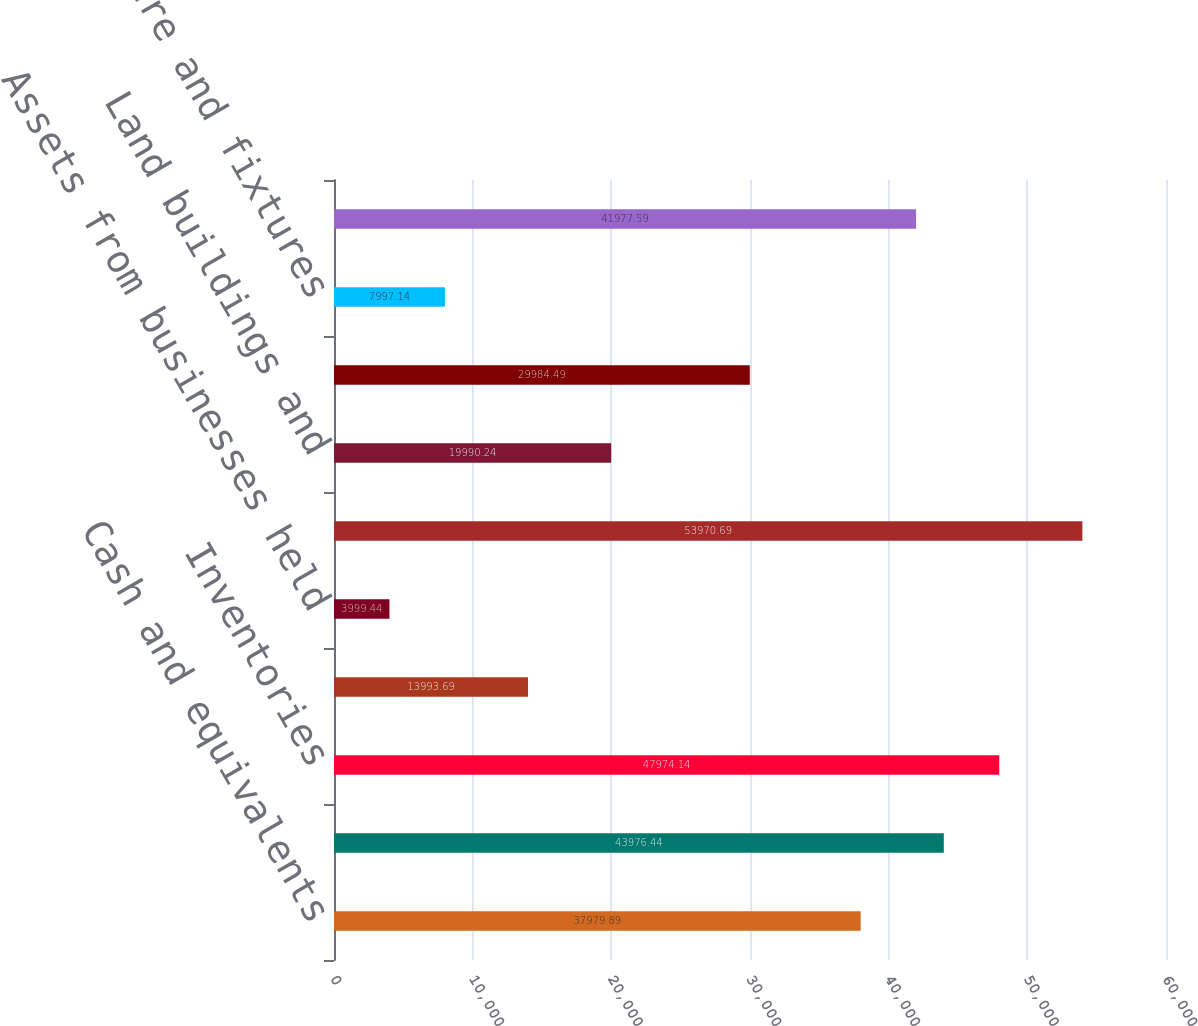<chart> <loc_0><loc_0><loc_500><loc_500><bar_chart><fcel>Cash and equivalents<fcel>Trade receivables net<fcel>Inventories<fcel>Prepaid expenses and other<fcel>Assets from businesses held<fcel>Total current assets<fcel>Land buildings and<fcel>Machinery and equipment<fcel>Furniture and fixtures<fcel>Total property and equipment<nl><fcel>37979.9<fcel>43976.4<fcel>47974.1<fcel>13993.7<fcel>3999.44<fcel>53970.7<fcel>19990.2<fcel>29984.5<fcel>7997.14<fcel>41977.6<nl></chart> 